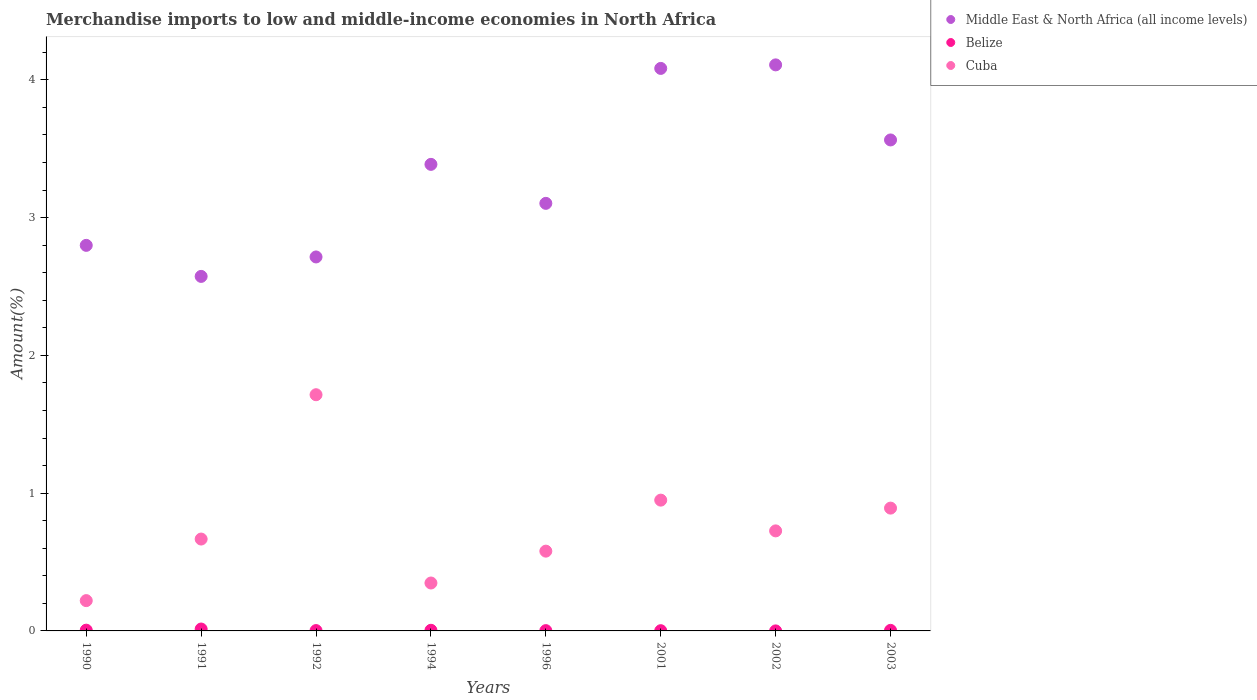How many different coloured dotlines are there?
Make the answer very short. 3. Is the number of dotlines equal to the number of legend labels?
Your answer should be very brief. Yes. What is the percentage of amount earned from merchandise imports in Middle East & North Africa (all income levels) in 1994?
Offer a very short reply. 3.39. Across all years, what is the maximum percentage of amount earned from merchandise imports in Middle East & North Africa (all income levels)?
Offer a very short reply. 4.11. Across all years, what is the minimum percentage of amount earned from merchandise imports in Belize?
Offer a very short reply. 0. What is the total percentage of amount earned from merchandise imports in Cuba in the graph?
Keep it short and to the point. 6.09. What is the difference between the percentage of amount earned from merchandise imports in Middle East & North Africa (all income levels) in 1991 and that in 1996?
Your answer should be compact. -0.53. What is the difference between the percentage of amount earned from merchandise imports in Middle East & North Africa (all income levels) in 2002 and the percentage of amount earned from merchandise imports in Belize in 2003?
Provide a short and direct response. 4.1. What is the average percentage of amount earned from merchandise imports in Middle East & North Africa (all income levels) per year?
Keep it short and to the point. 3.29. In the year 1992, what is the difference between the percentage of amount earned from merchandise imports in Belize and percentage of amount earned from merchandise imports in Middle East & North Africa (all income levels)?
Offer a terse response. -2.71. In how many years, is the percentage of amount earned from merchandise imports in Middle East & North Africa (all income levels) greater than 1.2 %?
Ensure brevity in your answer.  8. What is the ratio of the percentage of amount earned from merchandise imports in Belize in 1992 to that in 2003?
Offer a very short reply. 0.61. What is the difference between the highest and the second highest percentage of amount earned from merchandise imports in Middle East & North Africa (all income levels)?
Ensure brevity in your answer.  0.03. What is the difference between the highest and the lowest percentage of amount earned from merchandise imports in Belize?
Offer a terse response. 0.01. Is it the case that in every year, the sum of the percentage of amount earned from merchandise imports in Middle East & North Africa (all income levels) and percentage of amount earned from merchandise imports in Belize  is greater than the percentage of amount earned from merchandise imports in Cuba?
Ensure brevity in your answer.  Yes. How many dotlines are there?
Your response must be concise. 3. How many years are there in the graph?
Provide a short and direct response. 8. Does the graph contain any zero values?
Ensure brevity in your answer.  No. Where does the legend appear in the graph?
Your response must be concise. Top right. How many legend labels are there?
Ensure brevity in your answer.  3. How are the legend labels stacked?
Offer a terse response. Vertical. What is the title of the graph?
Keep it short and to the point. Merchandise imports to low and middle-income economies in North Africa. What is the label or title of the Y-axis?
Give a very brief answer. Amount(%). What is the Amount(%) of Middle East & North Africa (all income levels) in 1990?
Your response must be concise. 2.8. What is the Amount(%) of Belize in 1990?
Offer a terse response. 0.01. What is the Amount(%) of Cuba in 1990?
Ensure brevity in your answer.  0.22. What is the Amount(%) in Middle East & North Africa (all income levels) in 1991?
Keep it short and to the point. 2.57. What is the Amount(%) of Belize in 1991?
Your answer should be compact. 0.01. What is the Amount(%) of Cuba in 1991?
Your answer should be very brief. 0.67. What is the Amount(%) of Middle East & North Africa (all income levels) in 1992?
Ensure brevity in your answer.  2.71. What is the Amount(%) in Belize in 1992?
Provide a succinct answer. 0. What is the Amount(%) of Cuba in 1992?
Make the answer very short. 1.71. What is the Amount(%) in Middle East & North Africa (all income levels) in 1994?
Your response must be concise. 3.39. What is the Amount(%) in Belize in 1994?
Your response must be concise. 0. What is the Amount(%) of Cuba in 1994?
Keep it short and to the point. 0.35. What is the Amount(%) in Middle East & North Africa (all income levels) in 1996?
Offer a terse response. 3.1. What is the Amount(%) in Belize in 1996?
Your response must be concise. 0. What is the Amount(%) in Cuba in 1996?
Keep it short and to the point. 0.58. What is the Amount(%) of Middle East & North Africa (all income levels) in 2001?
Make the answer very short. 4.08. What is the Amount(%) of Belize in 2001?
Offer a terse response. 0. What is the Amount(%) of Cuba in 2001?
Make the answer very short. 0.95. What is the Amount(%) in Middle East & North Africa (all income levels) in 2002?
Provide a short and direct response. 4.11. What is the Amount(%) in Belize in 2002?
Make the answer very short. 0. What is the Amount(%) of Cuba in 2002?
Give a very brief answer. 0.73. What is the Amount(%) in Middle East & North Africa (all income levels) in 2003?
Keep it short and to the point. 3.56. What is the Amount(%) of Belize in 2003?
Offer a terse response. 0. What is the Amount(%) in Cuba in 2003?
Offer a terse response. 0.89. Across all years, what is the maximum Amount(%) of Middle East & North Africa (all income levels)?
Offer a very short reply. 4.11. Across all years, what is the maximum Amount(%) of Belize?
Provide a succinct answer. 0.01. Across all years, what is the maximum Amount(%) in Cuba?
Your response must be concise. 1.71. Across all years, what is the minimum Amount(%) of Middle East & North Africa (all income levels)?
Your response must be concise. 2.57. Across all years, what is the minimum Amount(%) of Belize?
Provide a succinct answer. 0. Across all years, what is the minimum Amount(%) of Cuba?
Your response must be concise. 0.22. What is the total Amount(%) of Middle East & North Africa (all income levels) in the graph?
Give a very brief answer. 26.33. What is the total Amount(%) in Belize in the graph?
Keep it short and to the point. 0.03. What is the total Amount(%) of Cuba in the graph?
Provide a short and direct response. 6.09. What is the difference between the Amount(%) of Middle East & North Africa (all income levels) in 1990 and that in 1991?
Give a very brief answer. 0.23. What is the difference between the Amount(%) in Belize in 1990 and that in 1991?
Provide a succinct answer. -0.01. What is the difference between the Amount(%) of Cuba in 1990 and that in 1991?
Offer a terse response. -0.45. What is the difference between the Amount(%) in Middle East & North Africa (all income levels) in 1990 and that in 1992?
Your answer should be compact. 0.08. What is the difference between the Amount(%) in Belize in 1990 and that in 1992?
Your answer should be compact. 0. What is the difference between the Amount(%) in Cuba in 1990 and that in 1992?
Keep it short and to the point. -1.49. What is the difference between the Amount(%) in Middle East & North Africa (all income levels) in 1990 and that in 1994?
Make the answer very short. -0.59. What is the difference between the Amount(%) in Belize in 1990 and that in 1994?
Offer a terse response. 0. What is the difference between the Amount(%) of Cuba in 1990 and that in 1994?
Your answer should be very brief. -0.13. What is the difference between the Amount(%) of Middle East & North Africa (all income levels) in 1990 and that in 1996?
Provide a short and direct response. -0.3. What is the difference between the Amount(%) of Belize in 1990 and that in 1996?
Keep it short and to the point. 0. What is the difference between the Amount(%) in Cuba in 1990 and that in 1996?
Offer a very short reply. -0.36. What is the difference between the Amount(%) of Middle East & North Africa (all income levels) in 1990 and that in 2001?
Make the answer very short. -1.28. What is the difference between the Amount(%) in Belize in 1990 and that in 2001?
Your answer should be compact. 0. What is the difference between the Amount(%) of Cuba in 1990 and that in 2001?
Offer a terse response. -0.73. What is the difference between the Amount(%) in Middle East & North Africa (all income levels) in 1990 and that in 2002?
Keep it short and to the point. -1.31. What is the difference between the Amount(%) in Belize in 1990 and that in 2002?
Provide a succinct answer. 0.01. What is the difference between the Amount(%) in Cuba in 1990 and that in 2002?
Offer a terse response. -0.51. What is the difference between the Amount(%) in Middle East & North Africa (all income levels) in 1990 and that in 2003?
Provide a short and direct response. -0.77. What is the difference between the Amount(%) in Belize in 1990 and that in 2003?
Your answer should be very brief. 0. What is the difference between the Amount(%) in Cuba in 1990 and that in 2003?
Keep it short and to the point. -0.67. What is the difference between the Amount(%) of Middle East & North Africa (all income levels) in 1991 and that in 1992?
Your response must be concise. -0.14. What is the difference between the Amount(%) of Belize in 1991 and that in 1992?
Make the answer very short. 0.01. What is the difference between the Amount(%) of Cuba in 1991 and that in 1992?
Provide a succinct answer. -1.05. What is the difference between the Amount(%) in Middle East & North Africa (all income levels) in 1991 and that in 1994?
Make the answer very short. -0.81. What is the difference between the Amount(%) of Belize in 1991 and that in 1994?
Your answer should be very brief. 0.01. What is the difference between the Amount(%) in Cuba in 1991 and that in 1994?
Ensure brevity in your answer.  0.32. What is the difference between the Amount(%) in Middle East & North Africa (all income levels) in 1991 and that in 1996?
Your response must be concise. -0.53. What is the difference between the Amount(%) of Belize in 1991 and that in 1996?
Ensure brevity in your answer.  0.01. What is the difference between the Amount(%) of Cuba in 1991 and that in 1996?
Offer a terse response. 0.09. What is the difference between the Amount(%) in Middle East & North Africa (all income levels) in 1991 and that in 2001?
Ensure brevity in your answer.  -1.51. What is the difference between the Amount(%) of Belize in 1991 and that in 2001?
Your answer should be very brief. 0.01. What is the difference between the Amount(%) of Cuba in 1991 and that in 2001?
Offer a very short reply. -0.28. What is the difference between the Amount(%) in Middle East & North Africa (all income levels) in 1991 and that in 2002?
Your response must be concise. -1.54. What is the difference between the Amount(%) of Belize in 1991 and that in 2002?
Your response must be concise. 0.01. What is the difference between the Amount(%) of Cuba in 1991 and that in 2002?
Your response must be concise. -0.06. What is the difference between the Amount(%) of Middle East & North Africa (all income levels) in 1991 and that in 2003?
Offer a very short reply. -0.99. What is the difference between the Amount(%) in Belize in 1991 and that in 2003?
Give a very brief answer. 0.01. What is the difference between the Amount(%) of Cuba in 1991 and that in 2003?
Your answer should be very brief. -0.22. What is the difference between the Amount(%) in Middle East & North Africa (all income levels) in 1992 and that in 1994?
Provide a short and direct response. -0.67. What is the difference between the Amount(%) in Belize in 1992 and that in 1994?
Provide a succinct answer. -0. What is the difference between the Amount(%) in Cuba in 1992 and that in 1994?
Provide a succinct answer. 1.37. What is the difference between the Amount(%) in Middle East & North Africa (all income levels) in 1992 and that in 1996?
Your answer should be compact. -0.39. What is the difference between the Amount(%) in Belize in 1992 and that in 1996?
Offer a terse response. 0. What is the difference between the Amount(%) in Cuba in 1992 and that in 1996?
Give a very brief answer. 1.14. What is the difference between the Amount(%) in Middle East & North Africa (all income levels) in 1992 and that in 2001?
Provide a short and direct response. -1.37. What is the difference between the Amount(%) in Belize in 1992 and that in 2001?
Provide a short and direct response. 0. What is the difference between the Amount(%) in Cuba in 1992 and that in 2001?
Your answer should be compact. 0.77. What is the difference between the Amount(%) of Middle East & North Africa (all income levels) in 1992 and that in 2002?
Your answer should be very brief. -1.39. What is the difference between the Amount(%) in Belize in 1992 and that in 2002?
Make the answer very short. 0. What is the difference between the Amount(%) in Cuba in 1992 and that in 2002?
Ensure brevity in your answer.  0.99. What is the difference between the Amount(%) of Middle East & North Africa (all income levels) in 1992 and that in 2003?
Offer a very short reply. -0.85. What is the difference between the Amount(%) in Belize in 1992 and that in 2003?
Your answer should be compact. -0. What is the difference between the Amount(%) in Cuba in 1992 and that in 2003?
Provide a short and direct response. 0.82. What is the difference between the Amount(%) in Middle East & North Africa (all income levels) in 1994 and that in 1996?
Ensure brevity in your answer.  0.28. What is the difference between the Amount(%) in Belize in 1994 and that in 1996?
Your answer should be compact. 0. What is the difference between the Amount(%) in Cuba in 1994 and that in 1996?
Keep it short and to the point. -0.23. What is the difference between the Amount(%) in Middle East & North Africa (all income levels) in 1994 and that in 2001?
Provide a short and direct response. -0.7. What is the difference between the Amount(%) in Belize in 1994 and that in 2001?
Keep it short and to the point. 0. What is the difference between the Amount(%) in Cuba in 1994 and that in 2001?
Your response must be concise. -0.6. What is the difference between the Amount(%) of Middle East & North Africa (all income levels) in 1994 and that in 2002?
Make the answer very short. -0.72. What is the difference between the Amount(%) in Belize in 1994 and that in 2002?
Offer a terse response. 0. What is the difference between the Amount(%) in Cuba in 1994 and that in 2002?
Keep it short and to the point. -0.38. What is the difference between the Amount(%) of Middle East & North Africa (all income levels) in 1994 and that in 2003?
Make the answer very short. -0.18. What is the difference between the Amount(%) of Cuba in 1994 and that in 2003?
Ensure brevity in your answer.  -0.54. What is the difference between the Amount(%) of Middle East & North Africa (all income levels) in 1996 and that in 2001?
Your answer should be compact. -0.98. What is the difference between the Amount(%) in Cuba in 1996 and that in 2001?
Ensure brevity in your answer.  -0.37. What is the difference between the Amount(%) in Middle East & North Africa (all income levels) in 1996 and that in 2002?
Your response must be concise. -1.01. What is the difference between the Amount(%) of Belize in 1996 and that in 2002?
Make the answer very short. 0. What is the difference between the Amount(%) in Cuba in 1996 and that in 2002?
Your answer should be compact. -0.15. What is the difference between the Amount(%) of Middle East & North Africa (all income levels) in 1996 and that in 2003?
Provide a short and direct response. -0.46. What is the difference between the Amount(%) in Belize in 1996 and that in 2003?
Provide a short and direct response. -0. What is the difference between the Amount(%) of Cuba in 1996 and that in 2003?
Your answer should be very brief. -0.31. What is the difference between the Amount(%) of Middle East & North Africa (all income levels) in 2001 and that in 2002?
Provide a short and direct response. -0.03. What is the difference between the Amount(%) of Belize in 2001 and that in 2002?
Your response must be concise. 0. What is the difference between the Amount(%) in Cuba in 2001 and that in 2002?
Your response must be concise. 0.22. What is the difference between the Amount(%) of Middle East & North Africa (all income levels) in 2001 and that in 2003?
Keep it short and to the point. 0.52. What is the difference between the Amount(%) of Belize in 2001 and that in 2003?
Provide a succinct answer. -0. What is the difference between the Amount(%) in Cuba in 2001 and that in 2003?
Your response must be concise. 0.06. What is the difference between the Amount(%) of Middle East & North Africa (all income levels) in 2002 and that in 2003?
Ensure brevity in your answer.  0.54. What is the difference between the Amount(%) in Belize in 2002 and that in 2003?
Ensure brevity in your answer.  -0. What is the difference between the Amount(%) of Cuba in 2002 and that in 2003?
Offer a terse response. -0.17. What is the difference between the Amount(%) in Middle East & North Africa (all income levels) in 1990 and the Amount(%) in Belize in 1991?
Keep it short and to the point. 2.78. What is the difference between the Amount(%) in Middle East & North Africa (all income levels) in 1990 and the Amount(%) in Cuba in 1991?
Your answer should be very brief. 2.13. What is the difference between the Amount(%) in Belize in 1990 and the Amount(%) in Cuba in 1991?
Your answer should be compact. -0.66. What is the difference between the Amount(%) in Middle East & North Africa (all income levels) in 1990 and the Amount(%) in Belize in 1992?
Your response must be concise. 2.8. What is the difference between the Amount(%) of Middle East & North Africa (all income levels) in 1990 and the Amount(%) of Cuba in 1992?
Provide a short and direct response. 1.08. What is the difference between the Amount(%) of Belize in 1990 and the Amount(%) of Cuba in 1992?
Your response must be concise. -1.71. What is the difference between the Amount(%) in Middle East & North Africa (all income levels) in 1990 and the Amount(%) in Belize in 1994?
Your answer should be very brief. 2.79. What is the difference between the Amount(%) of Middle East & North Africa (all income levels) in 1990 and the Amount(%) of Cuba in 1994?
Provide a short and direct response. 2.45. What is the difference between the Amount(%) of Belize in 1990 and the Amount(%) of Cuba in 1994?
Offer a terse response. -0.34. What is the difference between the Amount(%) in Middle East & North Africa (all income levels) in 1990 and the Amount(%) in Belize in 1996?
Ensure brevity in your answer.  2.8. What is the difference between the Amount(%) of Middle East & North Africa (all income levels) in 1990 and the Amount(%) of Cuba in 1996?
Provide a succinct answer. 2.22. What is the difference between the Amount(%) of Belize in 1990 and the Amount(%) of Cuba in 1996?
Give a very brief answer. -0.57. What is the difference between the Amount(%) in Middle East & North Africa (all income levels) in 1990 and the Amount(%) in Belize in 2001?
Your answer should be very brief. 2.8. What is the difference between the Amount(%) in Middle East & North Africa (all income levels) in 1990 and the Amount(%) in Cuba in 2001?
Your answer should be very brief. 1.85. What is the difference between the Amount(%) in Belize in 1990 and the Amount(%) in Cuba in 2001?
Provide a short and direct response. -0.94. What is the difference between the Amount(%) in Middle East & North Africa (all income levels) in 1990 and the Amount(%) in Belize in 2002?
Provide a short and direct response. 2.8. What is the difference between the Amount(%) of Middle East & North Africa (all income levels) in 1990 and the Amount(%) of Cuba in 2002?
Provide a short and direct response. 2.07. What is the difference between the Amount(%) of Belize in 1990 and the Amount(%) of Cuba in 2002?
Offer a terse response. -0.72. What is the difference between the Amount(%) of Middle East & North Africa (all income levels) in 1990 and the Amount(%) of Belize in 2003?
Make the answer very short. 2.79. What is the difference between the Amount(%) of Middle East & North Africa (all income levels) in 1990 and the Amount(%) of Cuba in 2003?
Your response must be concise. 1.91. What is the difference between the Amount(%) in Belize in 1990 and the Amount(%) in Cuba in 2003?
Provide a succinct answer. -0.89. What is the difference between the Amount(%) of Middle East & North Africa (all income levels) in 1991 and the Amount(%) of Belize in 1992?
Your response must be concise. 2.57. What is the difference between the Amount(%) in Middle East & North Africa (all income levels) in 1991 and the Amount(%) in Cuba in 1992?
Make the answer very short. 0.86. What is the difference between the Amount(%) of Belize in 1991 and the Amount(%) of Cuba in 1992?
Offer a very short reply. -1.7. What is the difference between the Amount(%) of Middle East & North Africa (all income levels) in 1991 and the Amount(%) of Belize in 1994?
Your answer should be very brief. 2.57. What is the difference between the Amount(%) in Middle East & North Africa (all income levels) in 1991 and the Amount(%) in Cuba in 1994?
Offer a very short reply. 2.23. What is the difference between the Amount(%) of Belize in 1991 and the Amount(%) of Cuba in 1994?
Offer a terse response. -0.33. What is the difference between the Amount(%) in Middle East & North Africa (all income levels) in 1991 and the Amount(%) in Belize in 1996?
Your answer should be compact. 2.57. What is the difference between the Amount(%) of Middle East & North Africa (all income levels) in 1991 and the Amount(%) of Cuba in 1996?
Make the answer very short. 1.99. What is the difference between the Amount(%) in Belize in 1991 and the Amount(%) in Cuba in 1996?
Make the answer very short. -0.57. What is the difference between the Amount(%) in Middle East & North Africa (all income levels) in 1991 and the Amount(%) in Belize in 2001?
Offer a very short reply. 2.57. What is the difference between the Amount(%) in Middle East & North Africa (all income levels) in 1991 and the Amount(%) in Cuba in 2001?
Offer a terse response. 1.62. What is the difference between the Amount(%) of Belize in 1991 and the Amount(%) of Cuba in 2001?
Your response must be concise. -0.94. What is the difference between the Amount(%) of Middle East & North Africa (all income levels) in 1991 and the Amount(%) of Belize in 2002?
Offer a very short reply. 2.57. What is the difference between the Amount(%) in Middle East & North Africa (all income levels) in 1991 and the Amount(%) in Cuba in 2002?
Provide a short and direct response. 1.85. What is the difference between the Amount(%) of Belize in 1991 and the Amount(%) of Cuba in 2002?
Ensure brevity in your answer.  -0.71. What is the difference between the Amount(%) in Middle East & North Africa (all income levels) in 1991 and the Amount(%) in Belize in 2003?
Provide a succinct answer. 2.57. What is the difference between the Amount(%) in Middle East & North Africa (all income levels) in 1991 and the Amount(%) in Cuba in 2003?
Provide a succinct answer. 1.68. What is the difference between the Amount(%) of Belize in 1991 and the Amount(%) of Cuba in 2003?
Give a very brief answer. -0.88. What is the difference between the Amount(%) of Middle East & North Africa (all income levels) in 1992 and the Amount(%) of Belize in 1994?
Offer a very short reply. 2.71. What is the difference between the Amount(%) of Middle East & North Africa (all income levels) in 1992 and the Amount(%) of Cuba in 1994?
Offer a terse response. 2.37. What is the difference between the Amount(%) of Belize in 1992 and the Amount(%) of Cuba in 1994?
Provide a succinct answer. -0.35. What is the difference between the Amount(%) in Middle East & North Africa (all income levels) in 1992 and the Amount(%) in Belize in 1996?
Your response must be concise. 2.71. What is the difference between the Amount(%) of Middle East & North Africa (all income levels) in 1992 and the Amount(%) of Cuba in 1996?
Make the answer very short. 2.14. What is the difference between the Amount(%) of Belize in 1992 and the Amount(%) of Cuba in 1996?
Provide a short and direct response. -0.58. What is the difference between the Amount(%) in Middle East & North Africa (all income levels) in 1992 and the Amount(%) in Belize in 2001?
Ensure brevity in your answer.  2.71. What is the difference between the Amount(%) in Middle East & North Africa (all income levels) in 1992 and the Amount(%) in Cuba in 2001?
Ensure brevity in your answer.  1.76. What is the difference between the Amount(%) in Belize in 1992 and the Amount(%) in Cuba in 2001?
Provide a succinct answer. -0.95. What is the difference between the Amount(%) of Middle East & North Africa (all income levels) in 1992 and the Amount(%) of Belize in 2002?
Provide a succinct answer. 2.71. What is the difference between the Amount(%) of Middle East & North Africa (all income levels) in 1992 and the Amount(%) of Cuba in 2002?
Offer a very short reply. 1.99. What is the difference between the Amount(%) of Belize in 1992 and the Amount(%) of Cuba in 2002?
Provide a short and direct response. -0.72. What is the difference between the Amount(%) in Middle East & North Africa (all income levels) in 1992 and the Amount(%) in Belize in 2003?
Give a very brief answer. 2.71. What is the difference between the Amount(%) of Middle East & North Africa (all income levels) in 1992 and the Amount(%) of Cuba in 2003?
Your answer should be very brief. 1.82. What is the difference between the Amount(%) in Belize in 1992 and the Amount(%) in Cuba in 2003?
Your answer should be compact. -0.89. What is the difference between the Amount(%) in Middle East & North Africa (all income levels) in 1994 and the Amount(%) in Belize in 1996?
Give a very brief answer. 3.38. What is the difference between the Amount(%) of Middle East & North Africa (all income levels) in 1994 and the Amount(%) of Cuba in 1996?
Provide a succinct answer. 2.81. What is the difference between the Amount(%) of Belize in 1994 and the Amount(%) of Cuba in 1996?
Offer a terse response. -0.57. What is the difference between the Amount(%) of Middle East & North Africa (all income levels) in 1994 and the Amount(%) of Belize in 2001?
Make the answer very short. 3.38. What is the difference between the Amount(%) of Middle East & North Africa (all income levels) in 1994 and the Amount(%) of Cuba in 2001?
Your answer should be compact. 2.44. What is the difference between the Amount(%) of Belize in 1994 and the Amount(%) of Cuba in 2001?
Offer a terse response. -0.94. What is the difference between the Amount(%) in Middle East & North Africa (all income levels) in 1994 and the Amount(%) in Belize in 2002?
Your answer should be very brief. 3.39. What is the difference between the Amount(%) in Middle East & North Africa (all income levels) in 1994 and the Amount(%) in Cuba in 2002?
Your response must be concise. 2.66. What is the difference between the Amount(%) of Belize in 1994 and the Amount(%) of Cuba in 2002?
Offer a very short reply. -0.72. What is the difference between the Amount(%) of Middle East & North Africa (all income levels) in 1994 and the Amount(%) of Belize in 2003?
Provide a short and direct response. 3.38. What is the difference between the Amount(%) in Middle East & North Africa (all income levels) in 1994 and the Amount(%) in Cuba in 2003?
Offer a terse response. 2.5. What is the difference between the Amount(%) in Belize in 1994 and the Amount(%) in Cuba in 2003?
Offer a terse response. -0.89. What is the difference between the Amount(%) of Middle East & North Africa (all income levels) in 1996 and the Amount(%) of Belize in 2001?
Your answer should be compact. 3.1. What is the difference between the Amount(%) of Middle East & North Africa (all income levels) in 1996 and the Amount(%) of Cuba in 2001?
Provide a short and direct response. 2.15. What is the difference between the Amount(%) of Belize in 1996 and the Amount(%) of Cuba in 2001?
Provide a short and direct response. -0.95. What is the difference between the Amount(%) of Middle East & North Africa (all income levels) in 1996 and the Amount(%) of Belize in 2002?
Make the answer very short. 3.1. What is the difference between the Amount(%) of Middle East & North Africa (all income levels) in 1996 and the Amount(%) of Cuba in 2002?
Make the answer very short. 2.38. What is the difference between the Amount(%) in Belize in 1996 and the Amount(%) in Cuba in 2002?
Offer a terse response. -0.72. What is the difference between the Amount(%) in Middle East & North Africa (all income levels) in 1996 and the Amount(%) in Belize in 2003?
Provide a succinct answer. 3.1. What is the difference between the Amount(%) in Middle East & North Africa (all income levels) in 1996 and the Amount(%) in Cuba in 2003?
Your answer should be compact. 2.21. What is the difference between the Amount(%) in Belize in 1996 and the Amount(%) in Cuba in 2003?
Your answer should be compact. -0.89. What is the difference between the Amount(%) in Middle East & North Africa (all income levels) in 2001 and the Amount(%) in Belize in 2002?
Your response must be concise. 4.08. What is the difference between the Amount(%) in Middle East & North Africa (all income levels) in 2001 and the Amount(%) in Cuba in 2002?
Provide a short and direct response. 3.36. What is the difference between the Amount(%) of Belize in 2001 and the Amount(%) of Cuba in 2002?
Keep it short and to the point. -0.72. What is the difference between the Amount(%) in Middle East & North Africa (all income levels) in 2001 and the Amount(%) in Belize in 2003?
Give a very brief answer. 4.08. What is the difference between the Amount(%) of Middle East & North Africa (all income levels) in 2001 and the Amount(%) of Cuba in 2003?
Your response must be concise. 3.19. What is the difference between the Amount(%) of Belize in 2001 and the Amount(%) of Cuba in 2003?
Your response must be concise. -0.89. What is the difference between the Amount(%) of Middle East & North Africa (all income levels) in 2002 and the Amount(%) of Belize in 2003?
Provide a short and direct response. 4.1. What is the difference between the Amount(%) in Middle East & North Africa (all income levels) in 2002 and the Amount(%) in Cuba in 2003?
Ensure brevity in your answer.  3.22. What is the difference between the Amount(%) in Belize in 2002 and the Amount(%) in Cuba in 2003?
Provide a succinct answer. -0.89. What is the average Amount(%) of Middle East & North Africa (all income levels) per year?
Your answer should be very brief. 3.29. What is the average Amount(%) in Belize per year?
Offer a terse response. 0. What is the average Amount(%) in Cuba per year?
Offer a terse response. 0.76. In the year 1990, what is the difference between the Amount(%) in Middle East & North Africa (all income levels) and Amount(%) in Belize?
Make the answer very short. 2.79. In the year 1990, what is the difference between the Amount(%) in Middle East & North Africa (all income levels) and Amount(%) in Cuba?
Provide a succinct answer. 2.58. In the year 1990, what is the difference between the Amount(%) in Belize and Amount(%) in Cuba?
Offer a terse response. -0.21. In the year 1991, what is the difference between the Amount(%) in Middle East & North Africa (all income levels) and Amount(%) in Belize?
Ensure brevity in your answer.  2.56. In the year 1991, what is the difference between the Amount(%) of Middle East & North Africa (all income levels) and Amount(%) of Cuba?
Provide a short and direct response. 1.91. In the year 1991, what is the difference between the Amount(%) of Belize and Amount(%) of Cuba?
Provide a short and direct response. -0.65. In the year 1992, what is the difference between the Amount(%) of Middle East & North Africa (all income levels) and Amount(%) of Belize?
Ensure brevity in your answer.  2.71. In the year 1992, what is the difference between the Amount(%) in Belize and Amount(%) in Cuba?
Provide a succinct answer. -1.71. In the year 1994, what is the difference between the Amount(%) in Middle East & North Africa (all income levels) and Amount(%) in Belize?
Your answer should be compact. 3.38. In the year 1994, what is the difference between the Amount(%) of Middle East & North Africa (all income levels) and Amount(%) of Cuba?
Your response must be concise. 3.04. In the year 1994, what is the difference between the Amount(%) in Belize and Amount(%) in Cuba?
Provide a short and direct response. -0.34. In the year 1996, what is the difference between the Amount(%) of Middle East & North Africa (all income levels) and Amount(%) of Belize?
Give a very brief answer. 3.1. In the year 1996, what is the difference between the Amount(%) in Middle East & North Africa (all income levels) and Amount(%) in Cuba?
Make the answer very short. 2.52. In the year 1996, what is the difference between the Amount(%) of Belize and Amount(%) of Cuba?
Provide a short and direct response. -0.58. In the year 2001, what is the difference between the Amount(%) of Middle East & North Africa (all income levels) and Amount(%) of Belize?
Offer a terse response. 4.08. In the year 2001, what is the difference between the Amount(%) in Middle East & North Africa (all income levels) and Amount(%) in Cuba?
Give a very brief answer. 3.13. In the year 2001, what is the difference between the Amount(%) in Belize and Amount(%) in Cuba?
Provide a short and direct response. -0.95. In the year 2002, what is the difference between the Amount(%) in Middle East & North Africa (all income levels) and Amount(%) in Belize?
Offer a terse response. 4.11. In the year 2002, what is the difference between the Amount(%) in Middle East & North Africa (all income levels) and Amount(%) in Cuba?
Your answer should be very brief. 3.38. In the year 2002, what is the difference between the Amount(%) in Belize and Amount(%) in Cuba?
Give a very brief answer. -0.73. In the year 2003, what is the difference between the Amount(%) of Middle East & North Africa (all income levels) and Amount(%) of Belize?
Provide a short and direct response. 3.56. In the year 2003, what is the difference between the Amount(%) in Middle East & North Africa (all income levels) and Amount(%) in Cuba?
Provide a succinct answer. 2.67. In the year 2003, what is the difference between the Amount(%) of Belize and Amount(%) of Cuba?
Your answer should be very brief. -0.89. What is the ratio of the Amount(%) in Middle East & North Africa (all income levels) in 1990 to that in 1991?
Keep it short and to the point. 1.09. What is the ratio of the Amount(%) in Belize in 1990 to that in 1991?
Keep it short and to the point. 0.4. What is the ratio of the Amount(%) in Cuba in 1990 to that in 1991?
Your answer should be very brief. 0.33. What is the ratio of the Amount(%) of Middle East & North Africa (all income levels) in 1990 to that in 1992?
Provide a short and direct response. 1.03. What is the ratio of the Amount(%) of Belize in 1990 to that in 1992?
Offer a very short reply. 2.19. What is the ratio of the Amount(%) in Cuba in 1990 to that in 1992?
Make the answer very short. 0.13. What is the ratio of the Amount(%) in Middle East & North Africa (all income levels) in 1990 to that in 1994?
Provide a short and direct response. 0.83. What is the ratio of the Amount(%) in Belize in 1990 to that in 1994?
Give a very brief answer. 1.18. What is the ratio of the Amount(%) in Cuba in 1990 to that in 1994?
Offer a terse response. 0.63. What is the ratio of the Amount(%) of Middle East & North Africa (all income levels) in 1990 to that in 1996?
Ensure brevity in your answer.  0.9. What is the ratio of the Amount(%) of Belize in 1990 to that in 1996?
Give a very brief answer. 2.54. What is the ratio of the Amount(%) in Cuba in 1990 to that in 1996?
Make the answer very short. 0.38. What is the ratio of the Amount(%) of Middle East & North Africa (all income levels) in 1990 to that in 2001?
Your answer should be compact. 0.69. What is the ratio of the Amount(%) of Belize in 1990 to that in 2001?
Your answer should be compact. 3.33. What is the ratio of the Amount(%) of Cuba in 1990 to that in 2001?
Offer a terse response. 0.23. What is the ratio of the Amount(%) in Middle East & North Africa (all income levels) in 1990 to that in 2002?
Give a very brief answer. 0.68. What is the ratio of the Amount(%) in Belize in 1990 to that in 2002?
Your answer should be compact. 42.22. What is the ratio of the Amount(%) of Cuba in 1990 to that in 2002?
Keep it short and to the point. 0.3. What is the ratio of the Amount(%) of Middle East & North Africa (all income levels) in 1990 to that in 2003?
Your answer should be compact. 0.79. What is the ratio of the Amount(%) in Belize in 1990 to that in 2003?
Make the answer very short. 1.33. What is the ratio of the Amount(%) in Cuba in 1990 to that in 2003?
Ensure brevity in your answer.  0.25. What is the ratio of the Amount(%) of Middle East & North Africa (all income levels) in 1991 to that in 1992?
Provide a short and direct response. 0.95. What is the ratio of the Amount(%) in Belize in 1991 to that in 1992?
Provide a succinct answer. 5.52. What is the ratio of the Amount(%) in Cuba in 1991 to that in 1992?
Keep it short and to the point. 0.39. What is the ratio of the Amount(%) in Middle East & North Africa (all income levels) in 1991 to that in 1994?
Your answer should be compact. 0.76. What is the ratio of the Amount(%) of Belize in 1991 to that in 1994?
Give a very brief answer. 2.97. What is the ratio of the Amount(%) of Cuba in 1991 to that in 1994?
Offer a terse response. 1.92. What is the ratio of the Amount(%) of Middle East & North Africa (all income levels) in 1991 to that in 1996?
Ensure brevity in your answer.  0.83. What is the ratio of the Amount(%) in Belize in 1991 to that in 1996?
Your answer should be very brief. 6.4. What is the ratio of the Amount(%) in Cuba in 1991 to that in 1996?
Your answer should be very brief. 1.15. What is the ratio of the Amount(%) of Middle East & North Africa (all income levels) in 1991 to that in 2001?
Provide a succinct answer. 0.63. What is the ratio of the Amount(%) of Belize in 1991 to that in 2001?
Keep it short and to the point. 8.39. What is the ratio of the Amount(%) in Cuba in 1991 to that in 2001?
Ensure brevity in your answer.  0.7. What is the ratio of the Amount(%) of Middle East & North Africa (all income levels) in 1991 to that in 2002?
Give a very brief answer. 0.63. What is the ratio of the Amount(%) of Belize in 1991 to that in 2002?
Provide a short and direct response. 106.46. What is the ratio of the Amount(%) in Cuba in 1991 to that in 2002?
Your response must be concise. 0.92. What is the ratio of the Amount(%) in Middle East & North Africa (all income levels) in 1991 to that in 2003?
Offer a terse response. 0.72. What is the ratio of the Amount(%) in Belize in 1991 to that in 2003?
Provide a succinct answer. 3.36. What is the ratio of the Amount(%) of Cuba in 1991 to that in 2003?
Your answer should be very brief. 0.75. What is the ratio of the Amount(%) of Middle East & North Africa (all income levels) in 1992 to that in 1994?
Your response must be concise. 0.8. What is the ratio of the Amount(%) in Belize in 1992 to that in 1994?
Keep it short and to the point. 0.54. What is the ratio of the Amount(%) of Cuba in 1992 to that in 1994?
Offer a very short reply. 4.93. What is the ratio of the Amount(%) of Middle East & North Africa (all income levels) in 1992 to that in 1996?
Provide a short and direct response. 0.87. What is the ratio of the Amount(%) in Belize in 1992 to that in 1996?
Make the answer very short. 1.16. What is the ratio of the Amount(%) in Cuba in 1992 to that in 1996?
Provide a succinct answer. 2.96. What is the ratio of the Amount(%) in Middle East & North Africa (all income levels) in 1992 to that in 2001?
Give a very brief answer. 0.66. What is the ratio of the Amount(%) of Belize in 1992 to that in 2001?
Your answer should be compact. 1.52. What is the ratio of the Amount(%) in Cuba in 1992 to that in 2001?
Provide a short and direct response. 1.81. What is the ratio of the Amount(%) in Middle East & North Africa (all income levels) in 1992 to that in 2002?
Provide a succinct answer. 0.66. What is the ratio of the Amount(%) in Belize in 1992 to that in 2002?
Provide a succinct answer. 19.28. What is the ratio of the Amount(%) of Cuba in 1992 to that in 2002?
Your answer should be very brief. 2.36. What is the ratio of the Amount(%) in Middle East & North Africa (all income levels) in 1992 to that in 2003?
Provide a short and direct response. 0.76. What is the ratio of the Amount(%) in Belize in 1992 to that in 2003?
Give a very brief answer. 0.61. What is the ratio of the Amount(%) of Cuba in 1992 to that in 2003?
Ensure brevity in your answer.  1.92. What is the ratio of the Amount(%) of Middle East & North Africa (all income levels) in 1994 to that in 1996?
Your answer should be compact. 1.09. What is the ratio of the Amount(%) of Belize in 1994 to that in 1996?
Give a very brief answer. 2.15. What is the ratio of the Amount(%) in Cuba in 1994 to that in 1996?
Offer a terse response. 0.6. What is the ratio of the Amount(%) of Middle East & North Africa (all income levels) in 1994 to that in 2001?
Your answer should be very brief. 0.83. What is the ratio of the Amount(%) in Belize in 1994 to that in 2001?
Keep it short and to the point. 2.82. What is the ratio of the Amount(%) in Cuba in 1994 to that in 2001?
Your answer should be very brief. 0.37. What is the ratio of the Amount(%) of Middle East & North Africa (all income levels) in 1994 to that in 2002?
Provide a succinct answer. 0.82. What is the ratio of the Amount(%) in Belize in 1994 to that in 2002?
Offer a very short reply. 35.79. What is the ratio of the Amount(%) of Cuba in 1994 to that in 2002?
Your answer should be very brief. 0.48. What is the ratio of the Amount(%) of Middle East & North Africa (all income levels) in 1994 to that in 2003?
Give a very brief answer. 0.95. What is the ratio of the Amount(%) in Belize in 1994 to that in 2003?
Offer a very short reply. 1.13. What is the ratio of the Amount(%) in Cuba in 1994 to that in 2003?
Offer a terse response. 0.39. What is the ratio of the Amount(%) in Middle East & North Africa (all income levels) in 1996 to that in 2001?
Your answer should be compact. 0.76. What is the ratio of the Amount(%) of Belize in 1996 to that in 2001?
Give a very brief answer. 1.31. What is the ratio of the Amount(%) of Cuba in 1996 to that in 2001?
Ensure brevity in your answer.  0.61. What is the ratio of the Amount(%) in Middle East & North Africa (all income levels) in 1996 to that in 2002?
Give a very brief answer. 0.76. What is the ratio of the Amount(%) of Belize in 1996 to that in 2002?
Keep it short and to the point. 16.62. What is the ratio of the Amount(%) of Cuba in 1996 to that in 2002?
Ensure brevity in your answer.  0.8. What is the ratio of the Amount(%) of Middle East & North Africa (all income levels) in 1996 to that in 2003?
Ensure brevity in your answer.  0.87. What is the ratio of the Amount(%) of Belize in 1996 to that in 2003?
Offer a very short reply. 0.52. What is the ratio of the Amount(%) in Cuba in 1996 to that in 2003?
Your answer should be compact. 0.65. What is the ratio of the Amount(%) of Middle East & North Africa (all income levels) in 2001 to that in 2002?
Your answer should be very brief. 0.99. What is the ratio of the Amount(%) in Belize in 2001 to that in 2002?
Your answer should be very brief. 12.69. What is the ratio of the Amount(%) of Cuba in 2001 to that in 2002?
Provide a succinct answer. 1.31. What is the ratio of the Amount(%) of Middle East & North Africa (all income levels) in 2001 to that in 2003?
Provide a short and direct response. 1.15. What is the ratio of the Amount(%) in Belize in 2001 to that in 2003?
Keep it short and to the point. 0.4. What is the ratio of the Amount(%) of Cuba in 2001 to that in 2003?
Ensure brevity in your answer.  1.06. What is the ratio of the Amount(%) in Middle East & North Africa (all income levels) in 2002 to that in 2003?
Provide a short and direct response. 1.15. What is the ratio of the Amount(%) of Belize in 2002 to that in 2003?
Ensure brevity in your answer.  0.03. What is the ratio of the Amount(%) of Cuba in 2002 to that in 2003?
Give a very brief answer. 0.81. What is the difference between the highest and the second highest Amount(%) in Middle East & North Africa (all income levels)?
Ensure brevity in your answer.  0.03. What is the difference between the highest and the second highest Amount(%) of Belize?
Give a very brief answer. 0.01. What is the difference between the highest and the second highest Amount(%) of Cuba?
Offer a very short reply. 0.77. What is the difference between the highest and the lowest Amount(%) of Middle East & North Africa (all income levels)?
Offer a very short reply. 1.54. What is the difference between the highest and the lowest Amount(%) of Belize?
Offer a very short reply. 0.01. What is the difference between the highest and the lowest Amount(%) of Cuba?
Offer a terse response. 1.49. 